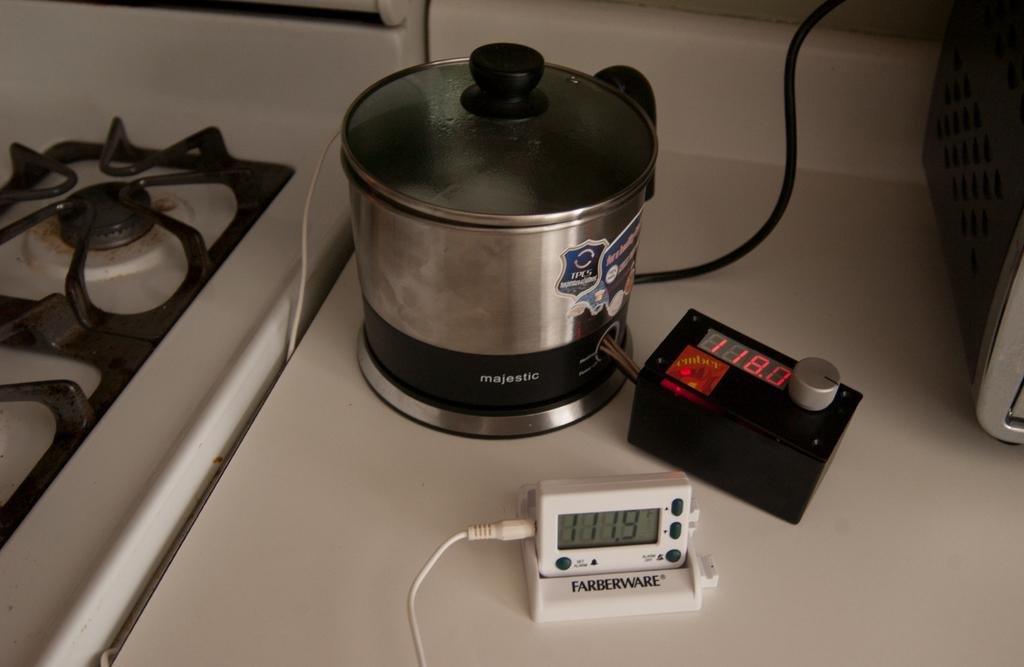<image>
Render a clear and concise summary of the photo. A black and silver cooking pot is made by the Majestic company. 